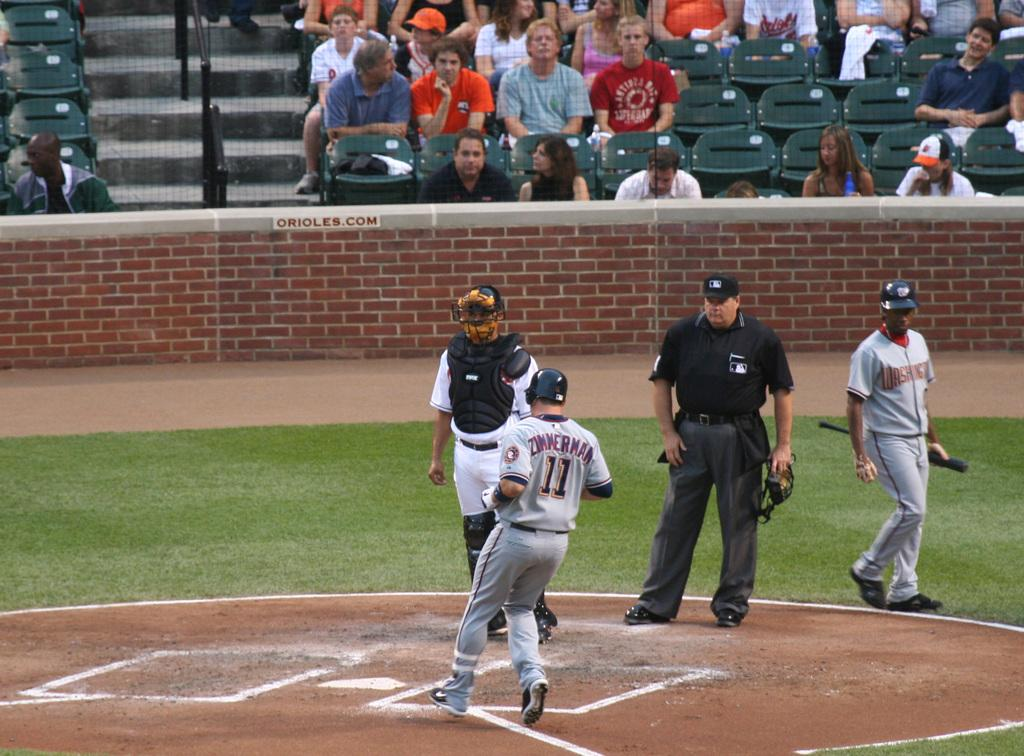<image>
Share a concise interpretation of the image provided. Zimmerman is running from third base to home plate during a baseball game. 